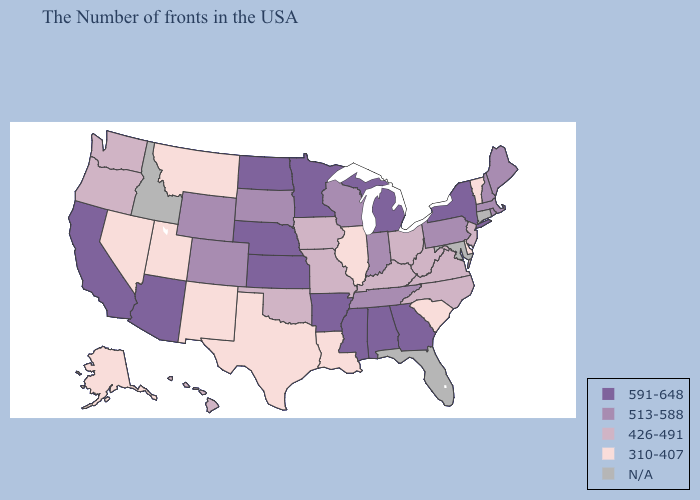Does Alaska have the highest value in the USA?
Quick response, please. No. Which states hav the highest value in the Northeast?
Concise answer only. New York. Which states hav the highest value in the South?
Quick response, please. Georgia, Alabama, Mississippi, Arkansas. Name the states that have a value in the range 591-648?
Write a very short answer. New York, Georgia, Michigan, Alabama, Mississippi, Arkansas, Minnesota, Kansas, Nebraska, North Dakota, Arizona, California. What is the lowest value in the South?
Answer briefly. 310-407. What is the value of Illinois?
Be succinct. 310-407. Among the states that border Tennessee , does Alabama have the highest value?
Quick response, please. Yes. How many symbols are there in the legend?
Write a very short answer. 5. Among the states that border South Carolina , does North Carolina have the highest value?
Write a very short answer. No. Is the legend a continuous bar?
Be succinct. No. What is the value of Maryland?
Concise answer only. N/A. What is the lowest value in the USA?
Quick response, please. 310-407. What is the value of Nebraska?
Answer briefly. 591-648. Does Delaware have the lowest value in the USA?
Answer briefly. Yes. 